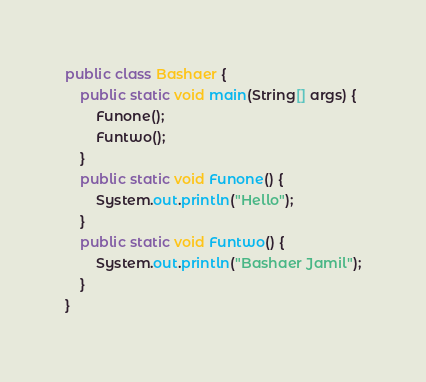Convert code to text. <code><loc_0><loc_0><loc_500><loc_500><_Java_>public class Bashaer {
    public static void main(String[] args) {
        Funone();
        Funtwo();
    }
    public static void Funone() {
        System.out.println("Hello");
    }
    public static void Funtwo() {
        System.out.println("Bashaer Jamil");
    }
}</code> 